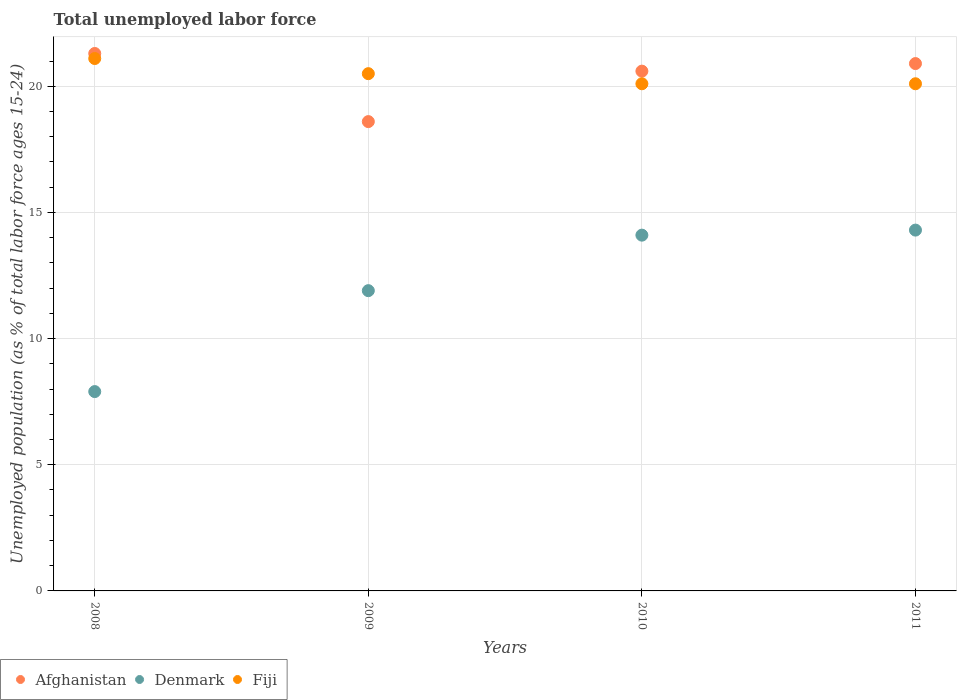What is the percentage of unemployed population in in Afghanistan in 2008?
Your answer should be very brief. 21.3. Across all years, what is the maximum percentage of unemployed population in in Fiji?
Your answer should be very brief. 21.1. Across all years, what is the minimum percentage of unemployed population in in Afghanistan?
Offer a very short reply. 18.6. In which year was the percentage of unemployed population in in Fiji minimum?
Your response must be concise. 2010. What is the total percentage of unemployed population in in Denmark in the graph?
Make the answer very short. 48.2. What is the difference between the percentage of unemployed population in in Afghanistan in 2010 and that in 2011?
Keep it short and to the point. -0.3. What is the difference between the percentage of unemployed population in in Afghanistan in 2011 and the percentage of unemployed population in in Denmark in 2010?
Your answer should be compact. 6.8. What is the average percentage of unemployed population in in Fiji per year?
Your answer should be very brief. 20.45. In the year 2008, what is the difference between the percentage of unemployed population in in Fiji and percentage of unemployed population in in Afghanistan?
Keep it short and to the point. -0.2. What is the ratio of the percentage of unemployed population in in Afghanistan in 2008 to that in 2009?
Offer a very short reply. 1.15. Is the percentage of unemployed population in in Afghanistan in 2009 less than that in 2011?
Offer a terse response. Yes. What is the difference between the highest and the second highest percentage of unemployed population in in Afghanistan?
Offer a very short reply. 0.4. What is the difference between the highest and the lowest percentage of unemployed population in in Afghanistan?
Offer a very short reply. 2.7. Is the sum of the percentage of unemployed population in in Denmark in 2008 and 2011 greater than the maximum percentage of unemployed population in in Afghanistan across all years?
Your answer should be compact. Yes. Is it the case that in every year, the sum of the percentage of unemployed population in in Afghanistan and percentage of unemployed population in in Denmark  is greater than the percentage of unemployed population in in Fiji?
Provide a succinct answer. Yes. Is the percentage of unemployed population in in Denmark strictly greater than the percentage of unemployed population in in Fiji over the years?
Give a very brief answer. No. How many dotlines are there?
Offer a very short reply. 3. What is the difference between two consecutive major ticks on the Y-axis?
Offer a very short reply. 5. Does the graph contain any zero values?
Give a very brief answer. No. Where does the legend appear in the graph?
Offer a terse response. Bottom left. What is the title of the graph?
Provide a short and direct response. Total unemployed labor force. What is the label or title of the Y-axis?
Your response must be concise. Unemployed population (as % of total labor force ages 15-24). What is the Unemployed population (as % of total labor force ages 15-24) of Afghanistan in 2008?
Your response must be concise. 21.3. What is the Unemployed population (as % of total labor force ages 15-24) of Denmark in 2008?
Give a very brief answer. 7.9. What is the Unemployed population (as % of total labor force ages 15-24) in Fiji in 2008?
Give a very brief answer. 21.1. What is the Unemployed population (as % of total labor force ages 15-24) in Afghanistan in 2009?
Offer a very short reply. 18.6. What is the Unemployed population (as % of total labor force ages 15-24) of Denmark in 2009?
Your answer should be compact. 11.9. What is the Unemployed population (as % of total labor force ages 15-24) of Afghanistan in 2010?
Your response must be concise. 20.6. What is the Unemployed population (as % of total labor force ages 15-24) of Denmark in 2010?
Offer a terse response. 14.1. What is the Unemployed population (as % of total labor force ages 15-24) in Fiji in 2010?
Keep it short and to the point. 20.1. What is the Unemployed population (as % of total labor force ages 15-24) of Afghanistan in 2011?
Offer a terse response. 20.9. What is the Unemployed population (as % of total labor force ages 15-24) of Denmark in 2011?
Give a very brief answer. 14.3. What is the Unemployed population (as % of total labor force ages 15-24) of Fiji in 2011?
Provide a short and direct response. 20.1. Across all years, what is the maximum Unemployed population (as % of total labor force ages 15-24) of Afghanistan?
Make the answer very short. 21.3. Across all years, what is the maximum Unemployed population (as % of total labor force ages 15-24) in Denmark?
Your answer should be compact. 14.3. Across all years, what is the maximum Unemployed population (as % of total labor force ages 15-24) of Fiji?
Offer a very short reply. 21.1. Across all years, what is the minimum Unemployed population (as % of total labor force ages 15-24) in Afghanistan?
Provide a succinct answer. 18.6. Across all years, what is the minimum Unemployed population (as % of total labor force ages 15-24) in Denmark?
Offer a terse response. 7.9. Across all years, what is the minimum Unemployed population (as % of total labor force ages 15-24) of Fiji?
Offer a terse response. 20.1. What is the total Unemployed population (as % of total labor force ages 15-24) in Afghanistan in the graph?
Offer a very short reply. 81.4. What is the total Unemployed population (as % of total labor force ages 15-24) in Denmark in the graph?
Your response must be concise. 48.2. What is the total Unemployed population (as % of total labor force ages 15-24) in Fiji in the graph?
Provide a succinct answer. 81.8. What is the difference between the Unemployed population (as % of total labor force ages 15-24) in Denmark in 2008 and that in 2009?
Provide a succinct answer. -4. What is the difference between the Unemployed population (as % of total labor force ages 15-24) of Fiji in 2008 and that in 2009?
Your answer should be compact. 0.6. What is the difference between the Unemployed population (as % of total labor force ages 15-24) in Denmark in 2008 and that in 2010?
Give a very brief answer. -6.2. What is the difference between the Unemployed population (as % of total labor force ages 15-24) of Denmark in 2008 and that in 2011?
Make the answer very short. -6.4. What is the difference between the Unemployed population (as % of total labor force ages 15-24) in Denmark in 2009 and that in 2010?
Offer a terse response. -2.2. What is the difference between the Unemployed population (as % of total labor force ages 15-24) in Denmark in 2009 and that in 2011?
Give a very brief answer. -2.4. What is the difference between the Unemployed population (as % of total labor force ages 15-24) in Afghanistan in 2010 and that in 2011?
Offer a very short reply. -0.3. What is the difference between the Unemployed population (as % of total labor force ages 15-24) of Fiji in 2010 and that in 2011?
Provide a short and direct response. 0. What is the difference between the Unemployed population (as % of total labor force ages 15-24) of Denmark in 2008 and the Unemployed population (as % of total labor force ages 15-24) of Fiji in 2009?
Make the answer very short. -12.6. What is the difference between the Unemployed population (as % of total labor force ages 15-24) of Afghanistan in 2008 and the Unemployed population (as % of total labor force ages 15-24) of Fiji in 2010?
Ensure brevity in your answer.  1.2. What is the difference between the Unemployed population (as % of total labor force ages 15-24) in Afghanistan in 2008 and the Unemployed population (as % of total labor force ages 15-24) in Denmark in 2011?
Ensure brevity in your answer.  7. What is the difference between the Unemployed population (as % of total labor force ages 15-24) in Afghanistan in 2008 and the Unemployed population (as % of total labor force ages 15-24) in Fiji in 2011?
Offer a terse response. 1.2. What is the difference between the Unemployed population (as % of total labor force ages 15-24) of Denmark in 2008 and the Unemployed population (as % of total labor force ages 15-24) of Fiji in 2011?
Offer a terse response. -12.2. What is the difference between the Unemployed population (as % of total labor force ages 15-24) in Afghanistan in 2009 and the Unemployed population (as % of total labor force ages 15-24) in Fiji in 2010?
Give a very brief answer. -1.5. What is the difference between the Unemployed population (as % of total labor force ages 15-24) in Afghanistan in 2009 and the Unemployed population (as % of total labor force ages 15-24) in Denmark in 2011?
Give a very brief answer. 4.3. What is the difference between the Unemployed population (as % of total labor force ages 15-24) of Afghanistan in 2010 and the Unemployed population (as % of total labor force ages 15-24) of Fiji in 2011?
Your answer should be very brief. 0.5. What is the average Unemployed population (as % of total labor force ages 15-24) of Afghanistan per year?
Your response must be concise. 20.35. What is the average Unemployed population (as % of total labor force ages 15-24) in Denmark per year?
Keep it short and to the point. 12.05. What is the average Unemployed population (as % of total labor force ages 15-24) of Fiji per year?
Ensure brevity in your answer.  20.45. In the year 2008, what is the difference between the Unemployed population (as % of total labor force ages 15-24) of Denmark and Unemployed population (as % of total labor force ages 15-24) of Fiji?
Ensure brevity in your answer.  -13.2. In the year 2009, what is the difference between the Unemployed population (as % of total labor force ages 15-24) of Afghanistan and Unemployed population (as % of total labor force ages 15-24) of Denmark?
Your answer should be very brief. 6.7. In the year 2009, what is the difference between the Unemployed population (as % of total labor force ages 15-24) of Denmark and Unemployed population (as % of total labor force ages 15-24) of Fiji?
Your answer should be very brief. -8.6. In the year 2010, what is the difference between the Unemployed population (as % of total labor force ages 15-24) in Afghanistan and Unemployed population (as % of total labor force ages 15-24) in Fiji?
Your response must be concise. 0.5. In the year 2010, what is the difference between the Unemployed population (as % of total labor force ages 15-24) in Denmark and Unemployed population (as % of total labor force ages 15-24) in Fiji?
Make the answer very short. -6. In the year 2011, what is the difference between the Unemployed population (as % of total labor force ages 15-24) of Denmark and Unemployed population (as % of total labor force ages 15-24) of Fiji?
Ensure brevity in your answer.  -5.8. What is the ratio of the Unemployed population (as % of total labor force ages 15-24) in Afghanistan in 2008 to that in 2009?
Keep it short and to the point. 1.15. What is the ratio of the Unemployed population (as % of total labor force ages 15-24) in Denmark in 2008 to that in 2009?
Offer a terse response. 0.66. What is the ratio of the Unemployed population (as % of total labor force ages 15-24) in Fiji in 2008 to that in 2009?
Offer a terse response. 1.03. What is the ratio of the Unemployed population (as % of total labor force ages 15-24) in Afghanistan in 2008 to that in 2010?
Your answer should be very brief. 1.03. What is the ratio of the Unemployed population (as % of total labor force ages 15-24) in Denmark in 2008 to that in 2010?
Offer a terse response. 0.56. What is the ratio of the Unemployed population (as % of total labor force ages 15-24) of Fiji in 2008 to that in 2010?
Offer a terse response. 1.05. What is the ratio of the Unemployed population (as % of total labor force ages 15-24) in Afghanistan in 2008 to that in 2011?
Ensure brevity in your answer.  1.02. What is the ratio of the Unemployed population (as % of total labor force ages 15-24) in Denmark in 2008 to that in 2011?
Your answer should be compact. 0.55. What is the ratio of the Unemployed population (as % of total labor force ages 15-24) in Fiji in 2008 to that in 2011?
Ensure brevity in your answer.  1.05. What is the ratio of the Unemployed population (as % of total labor force ages 15-24) of Afghanistan in 2009 to that in 2010?
Offer a very short reply. 0.9. What is the ratio of the Unemployed population (as % of total labor force ages 15-24) of Denmark in 2009 to that in 2010?
Your answer should be compact. 0.84. What is the ratio of the Unemployed population (as % of total labor force ages 15-24) in Fiji in 2009 to that in 2010?
Your answer should be compact. 1.02. What is the ratio of the Unemployed population (as % of total labor force ages 15-24) of Afghanistan in 2009 to that in 2011?
Give a very brief answer. 0.89. What is the ratio of the Unemployed population (as % of total labor force ages 15-24) in Denmark in 2009 to that in 2011?
Give a very brief answer. 0.83. What is the ratio of the Unemployed population (as % of total labor force ages 15-24) of Fiji in 2009 to that in 2011?
Your answer should be compact. 1.02. What is the ratio of the Unemployed population (as % of total labor force ages 15-24) in Afghanistan in 2010 to that in 2011?
Make the answer very short. 0.99. What is the ratio of the Unemployed population (as % of total labor force ages 15-24) of Denmark in 2010 to that in 2011?
Ensure brevity in your answer.  0.99. What is the ratio of the Unemployed population (as % of total labor force ages 15-24) in Fiji in 2010 to that in 2011?
Keep it short and to the point. 1. What is the difference between the highest and the second highest Unemployed population (as % of total labor force ages 15-24) of Afghanistan?
Offer a terse response. 0.4. What is the difference between the highest and the lowest Unemployed population (as % of total labor force ages 15-24) in Afghanistan?
Make the answer very short. 2.7. What is the difference between the highest and the lowest Unemployed population (as % of total labor force ages 15-24) of Fiji?
Keep it short and to the point. 1. 